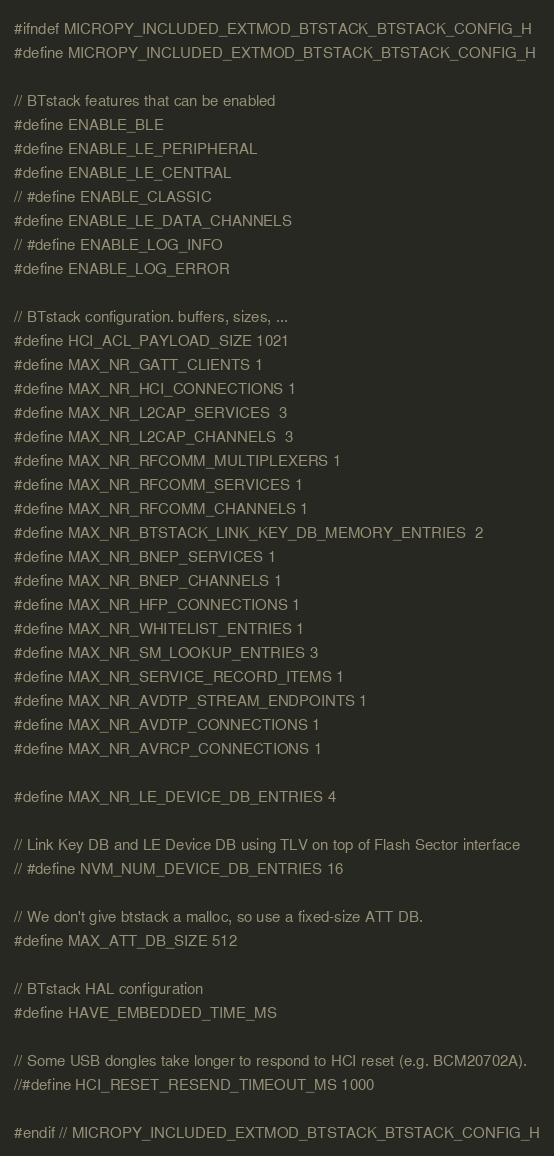Convert code to text. <code><loc_0><loc_0><loc_500><loc_500><_C_>#ifndef MICROPY_INCLUDED_EXTMOD_BTSTACK_BTSTACK_CONFIG_H
#define MICROPY_INCLUDED_EXTMOD_BTSTACK_BTSTACK_CONFIG_H

// BTstack features that can be enabled
#define ENABLE_BLE
#define ENABLE_LE_PERIPHERAL
#define ENABLE_LE_CENTRAL
// #define ENABLE_CLASSIC
#define ENABLE_LE_DATA_CHANNELS
// #define ENABLE_LOG_INFO
#define ENABLE_LOG_ERROR

// BTstack configuration. buffers, sizes, ...
#define HCI_ACL_PAYLOAD_SIZE 1021
#define MAX_NR_GATT_CLIENTS 1
#define MAX_NR_HCI_CONNECTIONS 1
#define MAX_NR_L2CAP_SERVICES  3
#define MAX_NR_L2CAP_CHANNELS  3
#define MAX_NR_RFCOMM_MULTIPLEXERS 1
#define MAX_NR_RFCOMM_SERVICES 1
#define MAX_NR_RFCOMM_CHANNELS 1
#define MAX_NR_BTSTACK_LINK_KEY_DB_MEMORY_ENTRIES  2
#define MAX_NR_BNEP_SERVICES 1
#define MAX_NR_BNEP_CHANNELS 1
#define MAX_NR_HFP_CONNECTIONS 1
#define MAX_NR_WHITELIST_ENTRIES 1
#define MAX_NR_SM_LOOKUP_ENTRIES 3
#define MAX_NR_SERVICE_RECORD_ITEMS 1
#define MAX_NR_AVDTP_STREAM_ENDPOINTS 1
#define MAX_NR_AVDTP_CONNECTIONS 1
#define MAX_NR_AVRCP_CONNECTIONS 1

#define MAX_NR_LE_DEVICE_DB_ENTRIES 4

// Link Key DB and LE Device DB using TLV on top of Flash Sector interface
// #define NVM_NUM_DEVICE_DB_ENTRIES 16

// We don't give btstack a malloc, so use a fixed-size ATT DB.
#define MAX_ATT_DB_SIZE 512

// BTstack HAL configuration
#define HAVE_EMBEDDED_TIME_MS

// Some USB dongles take longer to respond to HCI reset (e.g. BCM20702A).
//#define HCI_RESET_RESEND_TIMEOUT_MS 1000

#endif // MICROPY_INCLUDED_EXTMOD_BTSTACK_BTSTACK_CONFIG_H
</code> 